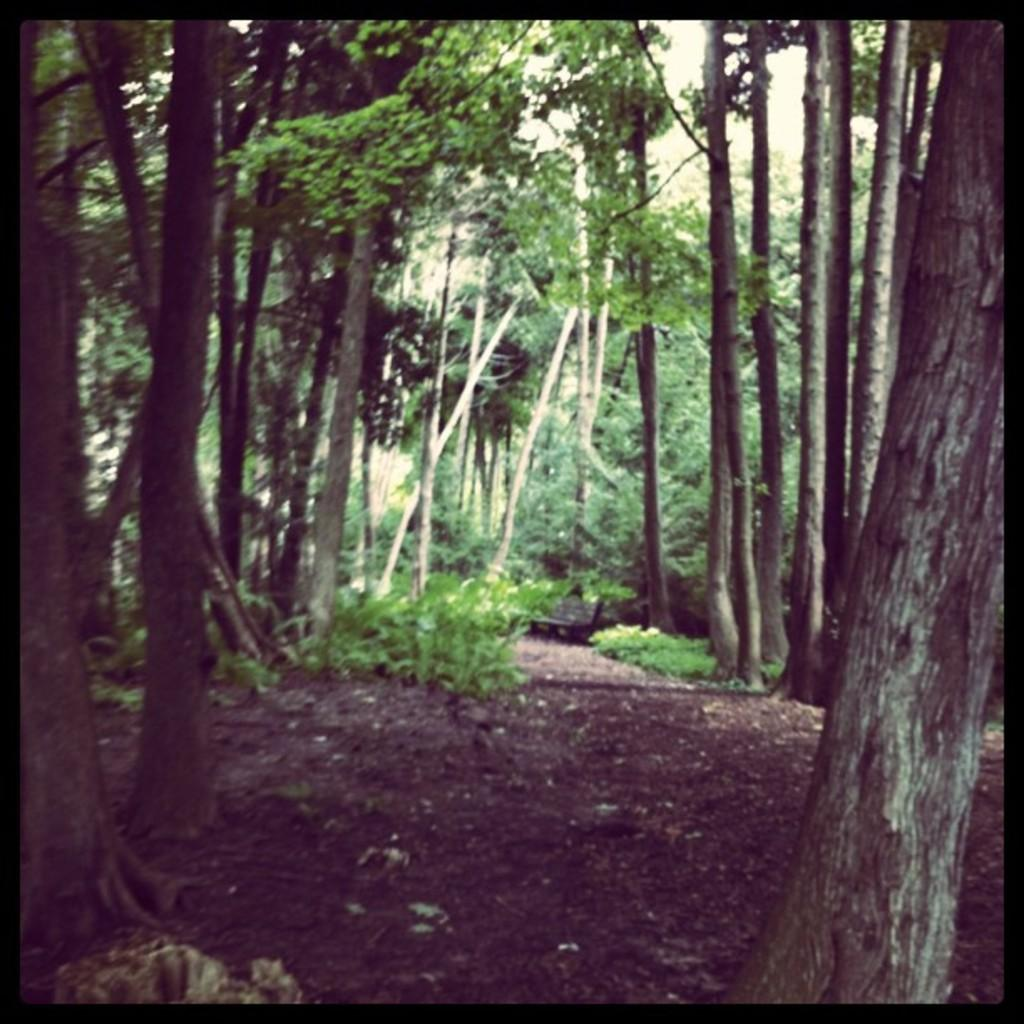What type of vegetation can be seen in the image? There are trees in the image. What part of the natural environment is visible in the image? The sky is visible in the image. Can you tell me how many turkeys are visible in the image? There are no turkeys present in the image. What is the size of the bit that is being used to take a bite out of the tree in the image? There is no bit or any indication of biting in the image; it features trees and the sky. 